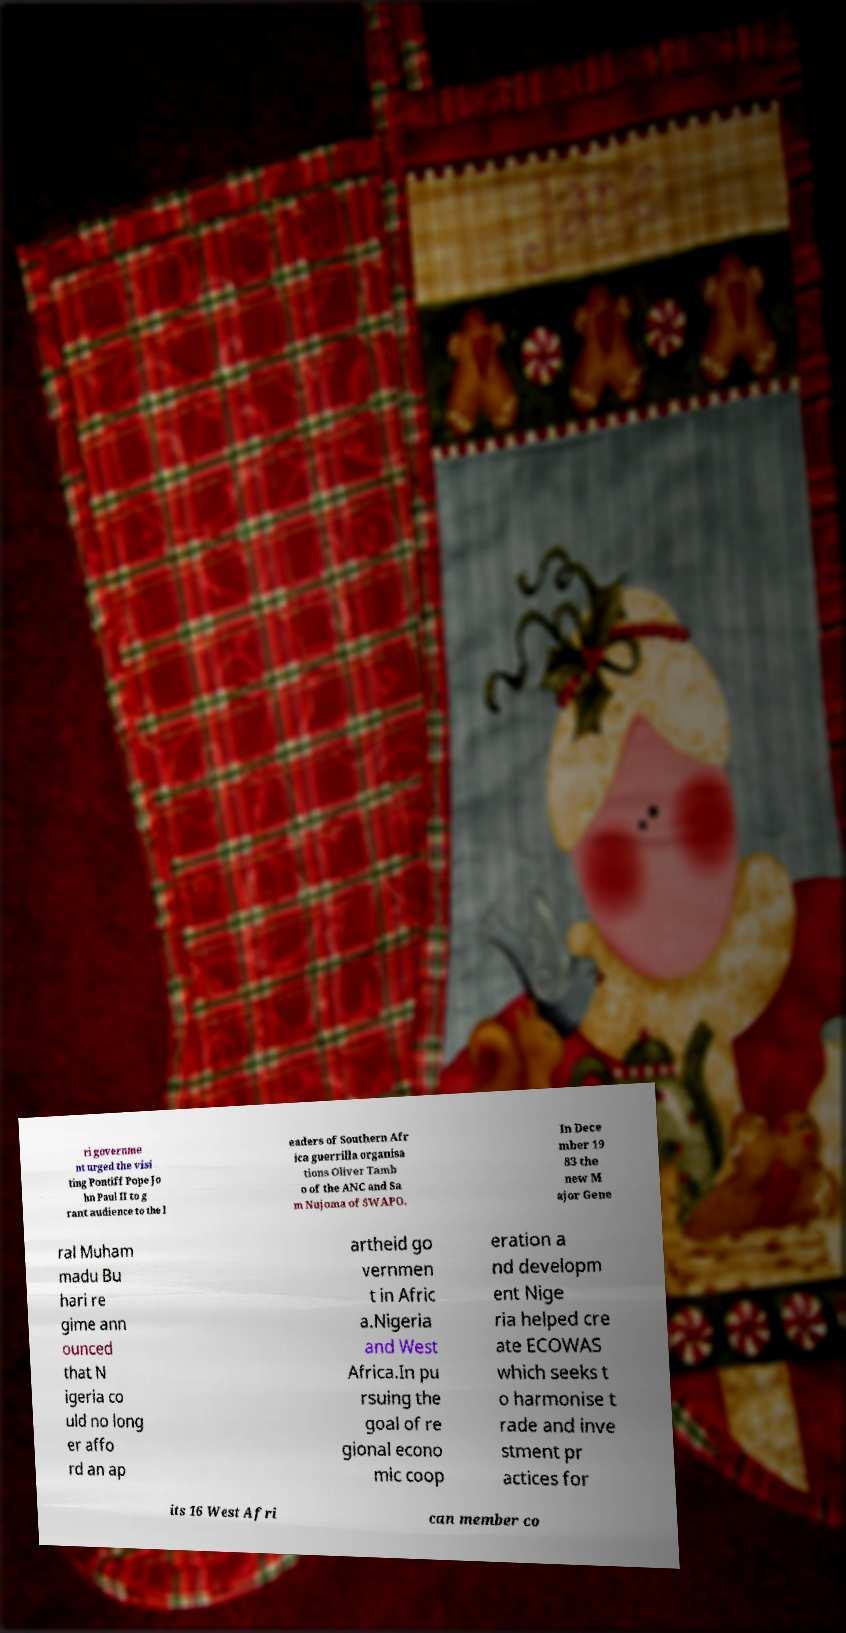What messages or text are displayed in this image? I need them in a readable, typed format. ri governme nt urged the visi ting Pontiff Pope Jo hn Paul II to g rant audience to the l eaders of Southern Afr ica guerrilla organisa tions Oliver Tamb o of the ANC and Sa m Nujoma of SWAPO. In Dece mber 19 83 the new M ajor Gene ral Muham madu Bu hari re gime ann ounced that N igeria co uld no long er affo rd an ap artheid go vernmen t in Afric a.Nigeria and West Africa.In pu rsuing the goal of re gional econo mic coop eration a nd developm ent Nige ria helped cre ate ECOWAS which seeks t o harmonise t rade and inve stment pr actices for its 16 West Afri can member co 